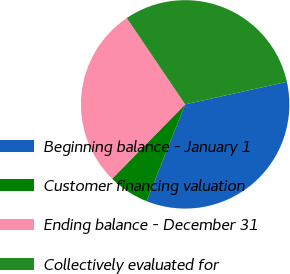Convert chart to OTSL. <chart><loc_0><loc_0><loc_500><loc_500><pie_chart><fcel>Beginning balance - January 1<fcel>Customer financing valuation<fcel>Ending balance - December 31<fcel>Collectively evaluated for<nl><fcel>34.5%<fcel>6.33%<fcel>28.18%<fcel>30.99%<nl></chart> 